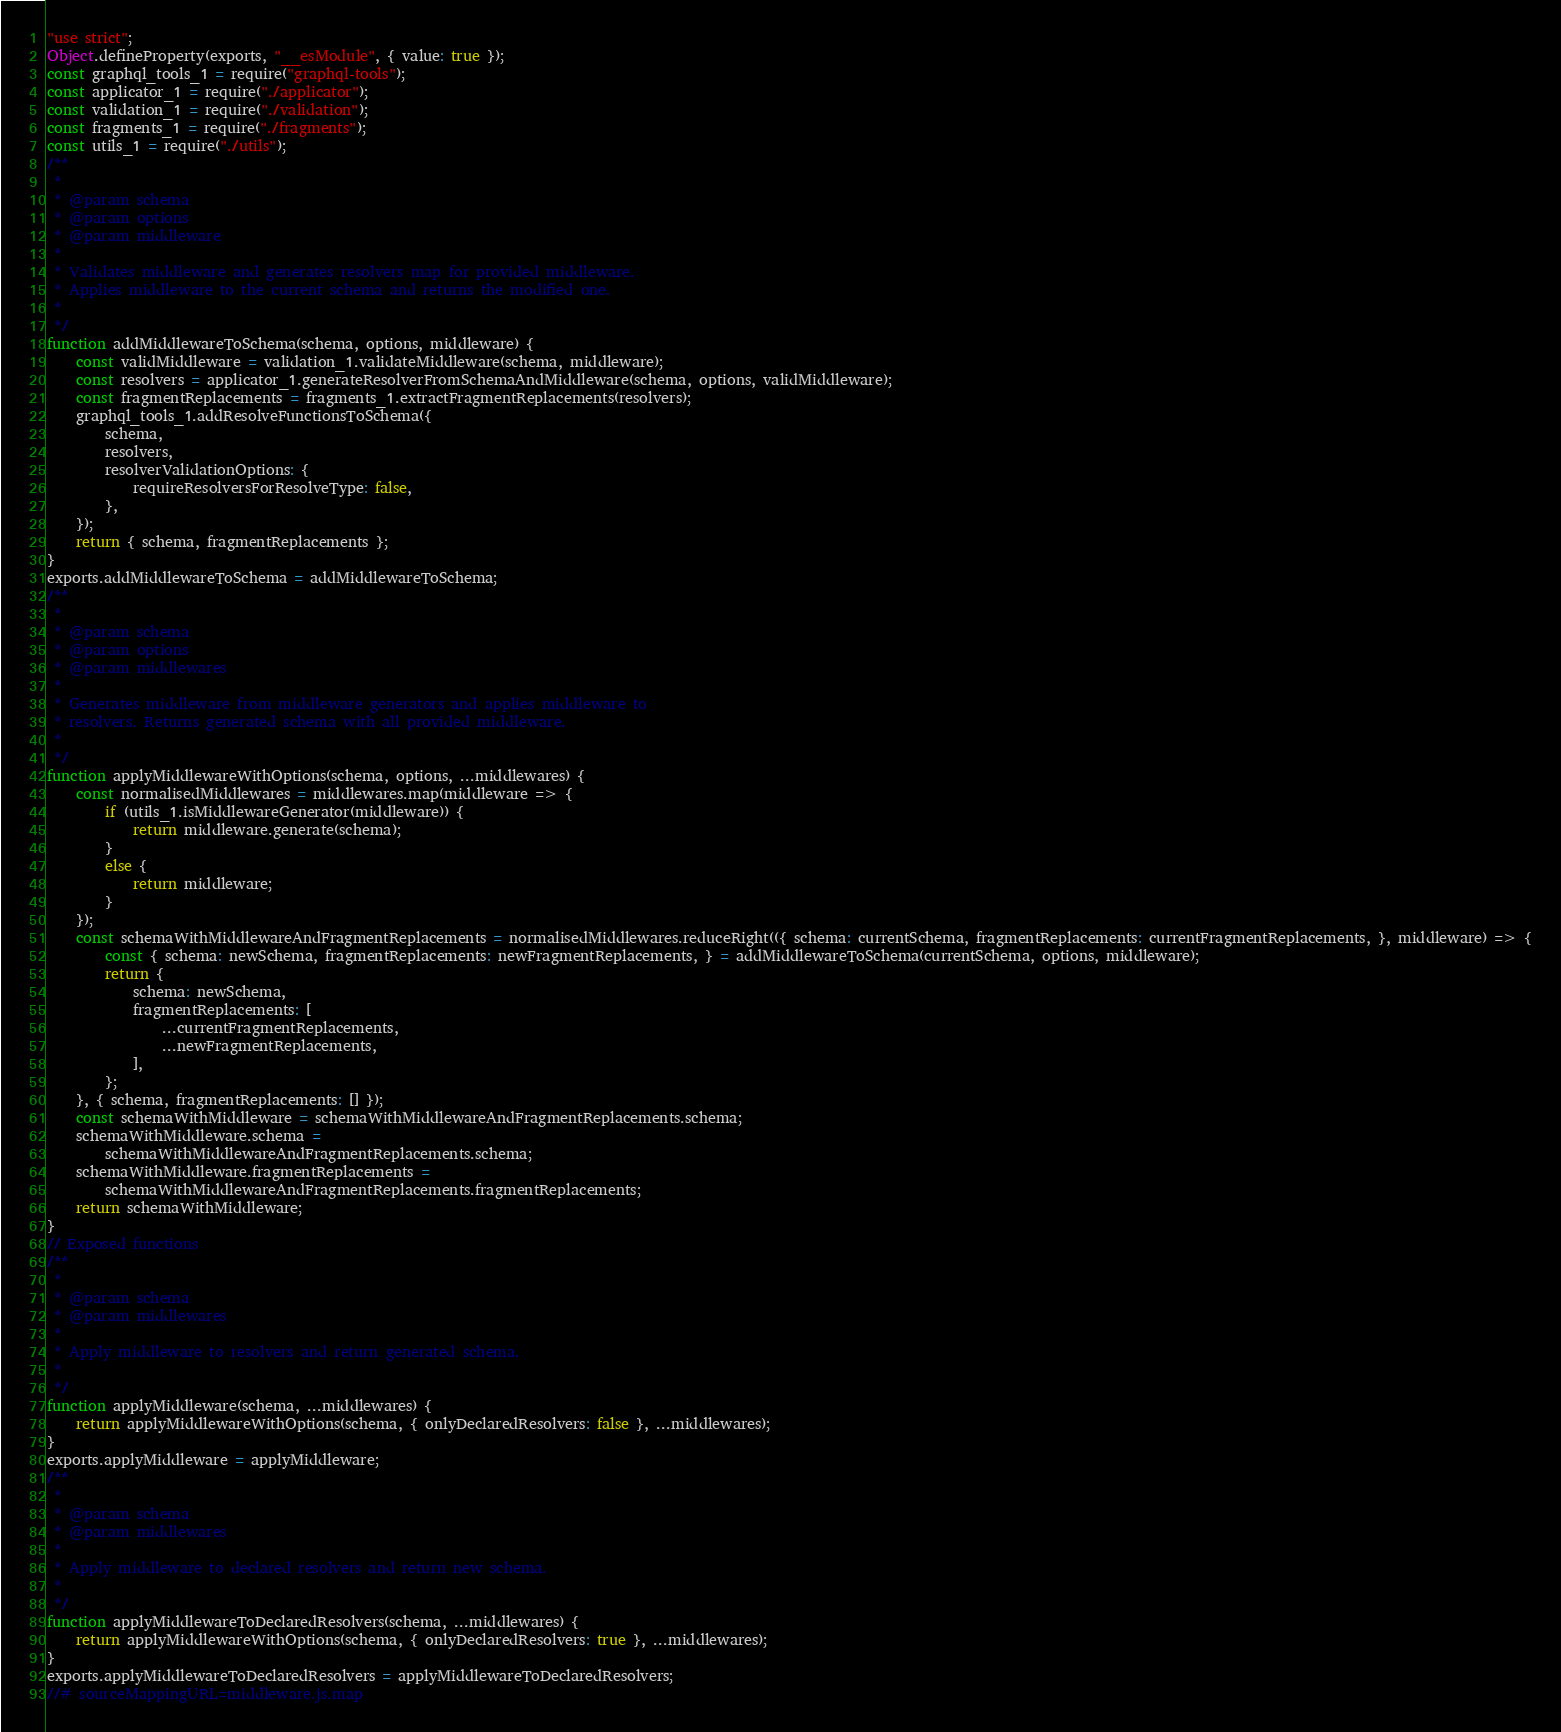Convert code to text. <code><loc_0><loc_0><loc_500><loc_500><_JavaScript_>"use strict";
Object.defineProperty(exports, "__esModule", { value: true });
const graphql_tools_1 = require("graphql-tools");
const applicator_1 = require("./applicator");
const validation_1 = require("./validation");
const fragments_1 = require("./fragments");
const utils_1 = require("./utils");
/**
 *
 * @param schema
 * @param options
 * @param middleware
 *
 * Validates middleware and generates resolvers map for provided middleware.
 * Applies middleware to the current schema and returns the modified one.
 *
 */
function addMiddlewareToSchema(schema, options, middleware) {
    const validMiddleware = validation_1.validateMiddleware(schema, middleware);
    const resolvers = applicator_1.generateResolverFromSchemaAndMiddleware(schema, options, validMiddleware);
    const fragmentReplacements = fragments_1.extractFragmentReplacements(resolvers);
    graphql_tools_1.addResolveFunctionsToSchema({
        schema,
        resolvers,
        resolverValidationOptions: {
            requireResolversForResolveType: false,
        },
    });
    return { schema, fragmentReplacements };
}
exports.addMiddlewareToSchema = addMiddlewareToSchema;
/**
 *
 * @param schema
 * @param options
 * @param middlewares
 *
 * Generates middleware from middleware generators and applies middleware to
 * resolvers. Returns generated schema with all provided middleware.
 *
 */
function applyMiddlewareWithOptions(schema, options, ...middlewares) {
    const normalisedMiddlewares = middlewares.map(middleware => {
        if (utils_1.isMiddlewareGenerator(middleware)) {
            return middleware.generate(schema);
        }
        else {
            return middleware;
        }
    });
    const schemaWithMiddlewareAndFragmentReplacements = normalisedMiddlewares.reduceRight(({ schema: currentSchema, fragmentReplacements: currentFragmentReplacements, }, middleware) => {
        const { schema: newSchema, fragmentReplacements: newFragmentReplacements, } = addMiddlewareToSchema(currentSchema, options, middleware);
        return {
            schema: newSchema,
            fragmentReplacements: [
                ...currentFragmentReplacements,
                ...newFragmentReplacements,
            ],
        };
    }, { schema, fragmentReplacements: [] });
    const schemaWithMiddleware = schemaWithMiddlewareAndFragmentReplacements.schema;
    schemaWithMiddleware.schema =
        schemaWithMiddlewareAndFragmentReplacements.schema;
    schemaWithMiddleware.fragmentReplacements =
        schemaWithMiddlewareAndFragmentReplacements.fragmentReplacements;
    return schemaWithMiddleware;
}
// Exposed functions
/**
 *
 * @param schema
 * @param middlewares
 *
 * Apply middleware to resolvers and return generated schema.
 *
 */
function applyMiddleware(schema, ...middlewares) {
    return applyMiddlewareWithOptions(schema, { onlyDeclaredResolvers: false }, ...middlewares);
}
exports.applyMiddleware = applyMiddleware;
/**
 *
 * @param schema
 * @param middlewares
 *
 * Apply middleware to declared resolvers and return new schema.
 *
 */
function applyMiddlewareToDeclaredResolvers(schema, ...middlewares) {
    return applyMiddlewareWithOptions(schema, { onlyDeclaredResolvers: true }, ...middlewares);
}
exports.applyMiddlewareToDeclaredResolvers = applyMiddlewareToDeclaredResolvers;
//# sourceMappingURL=middleware.js.map</code> 